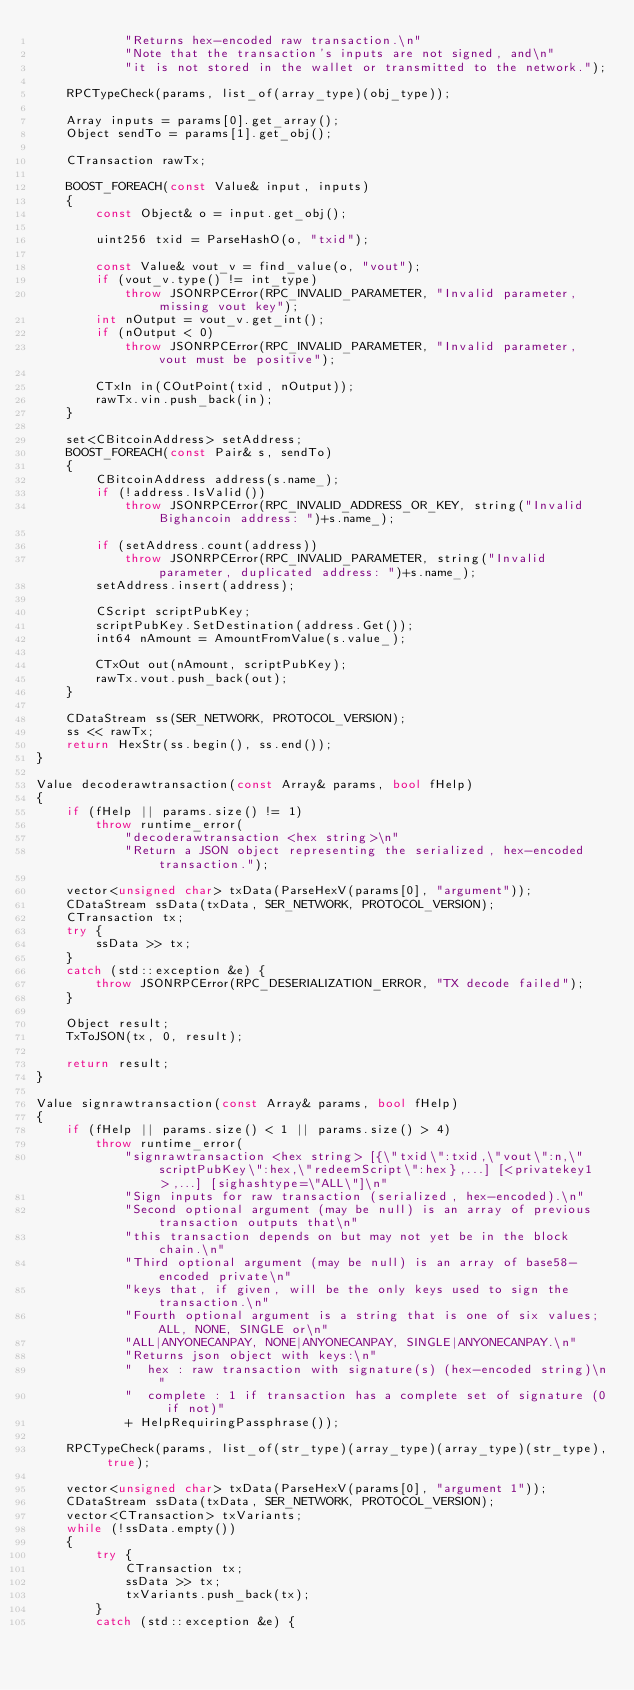Convert code to text. <code><loc_0><loc_0><loc_500><loc_500><_C++_>            "Returns hex-encoded raw transaction.\n"
            "Note that the transaction's inputs are not signed, and\n"
            "it is not stored in the wallet or transmitted to the network.");

    RPCTypeCheck(params, list_of(array_type)(obj_type));

    Array inputs = params[0].get_array();
    Object sendTo = params[1].get_obj();

    CTransaction rawTx;

    BOOST_FOREACH(const Value& input, inputs)
    {
        const Object& o = input.get_obj();

        uint256 txid = ParseHashO(o, "txid");

        const Value& vout_v = find_value(o, "vout");
        if (vout_v.type() != int_type)
            throw JSONRPCError(RPC_INVALID_PARAMETER, "Invalid parameter, missing vout key");
        int nOutput = vout_v.get_int();
        if (nOutput < 0)
            throw JSONRPCError(RPC_INVALID_PARAMETER, "Invalid parameter, vout must be positive");

        CTxIn in(COutPoint(txid, nOutput));
        rawTx.vin.push_back(in);
    }

    set<CBitcoinAddress> setAddress;
    BOOST_FOREACH(const Pair& s, sendTo)
    {
        CBitcoinAddress address(s.name_);
        if (!address.IsValid())
            throw JSONRPCError(RPC_INVALID_ADDRESS_OR_KEY, string("Invalid Bighancoin address: ")+s.name_);

        if (setAddress.count(address))
            throw JSONRPCError(RPC_INVALID_PARAMETER, string("Invalid parameter, duplicated address: ")+s.name_);
        setAddress.insert(address);

        CScript scriptPubKey;
        scriptPubKey.SetDestination(address.Get());
        int64 nAmount = AmountFromValue(s.value_);

        CTxOut out(nAmount, scriptPubKey);
        rawTx.vout.push_back(out);
    }

    CDataStream ss(SER_NETWORK, PROTOCOL_VERSION);
    ss << rawTx;
    return HexStr(ss.begin(), ss.end());
}

Value decoderawtransaction(const Array& params, bool fHelp)
{
    if (fHelp || params.size() != 1)
        throw runtime_error(
            "decoderawtransaction <hex string>\n"
            "Return a JSON object representing the serialized, hex-encoded transaction.");

    vector<unsigned char> txData(ParseHexV(params[0], "argument"));
    CDataStream ssData(txData, SER_NETWORK, PROTOCOL_VERSION);
    CTransaction tx;
    try {
        ssData >> tx;
    }
    catch (std::exception &e) {
        throw JSONRPCError(RPC_DESERIALIZATION_ERROR, "TX decode failed");
    }

    Object result;
    TxToJSON(tx, 0, result);

    return result;
}

Value signrawtransaction(const Array& params, bool fHelp)
{
    if (fHelp || params.size() < 1 || params.size() > 4)
        throw runtime_error(
            "signrawtransaction <hex string> [{\"txid\":txid,\"vout\":n,\"scriptPubKey\":hex,\"redeemScript\":hex},...] [<privatekey1>,...] [sighashtype=\"ALL\"]\n"
            "Sign inputs for raw transaction (serialized, hex-encoded).\n"
            "Second optional argument (may be null) is an array of previous transaction outputs that\n"
            "this transaction depends on but may not yet be in the block chain.\n"
            "Third optional argument (may be null) is an array of base58-encoded private\n"
            "keys that, if given, will be the only keys used to sign the transaction.\n"
            "Fourth optional argument is a string that is one of six values; ALL, NONE, SINGLE or\n"
            "ALL|ANYONECANPAY, NONE|ANYONECANPAY, SINGLE|ANYONECANPAY.\n"
            "Returns json object with keys:\n"
            "  hex : raw transaction with signature(s) (hex-encoded string)\n"
            "  complete : 1 if transaction has a complete set of signature (0 if not)"
            + HelpRequiringPassphrase());

    RPCTypeCheck(params, list_of(str_type)(array_type)(array_type)(str_type), true);

    vector<unsigned char> txData(ParseHexV(params[0], "argument 1"));
    CDataStream ssData(txData, SER_NETWORK, PROTOCOL_VERSION);
    vector<CTransaction> txVariants;
    while (!ssData.empty())
    {
        try {
            CTransaction tx;
            ssData >> tx;
            txVariants.push_back(tx);
        }
        catch (std::exception &e) {</code> 